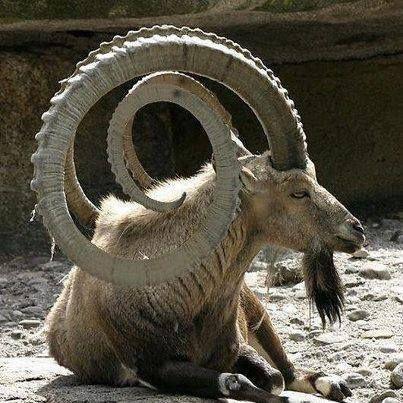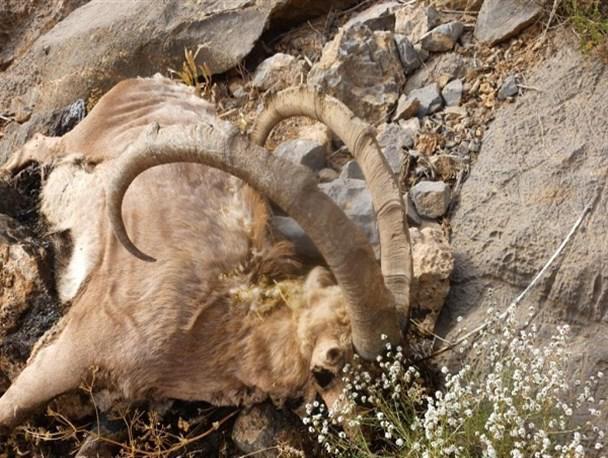The first image is the image on the left, the second image is the image on the right. Examine the images to the left and right. Is the description "The left and right image contains the same number of goats with at least one hunter holding its horns." accurate? Answer yes or no. No. The first image is the image on the left, the second image is the image on the right. Evaluate the accuracy of this statement regarding the images: "A man stands behind his hunting trophy.". Is it true? Answer yes or no. No. 